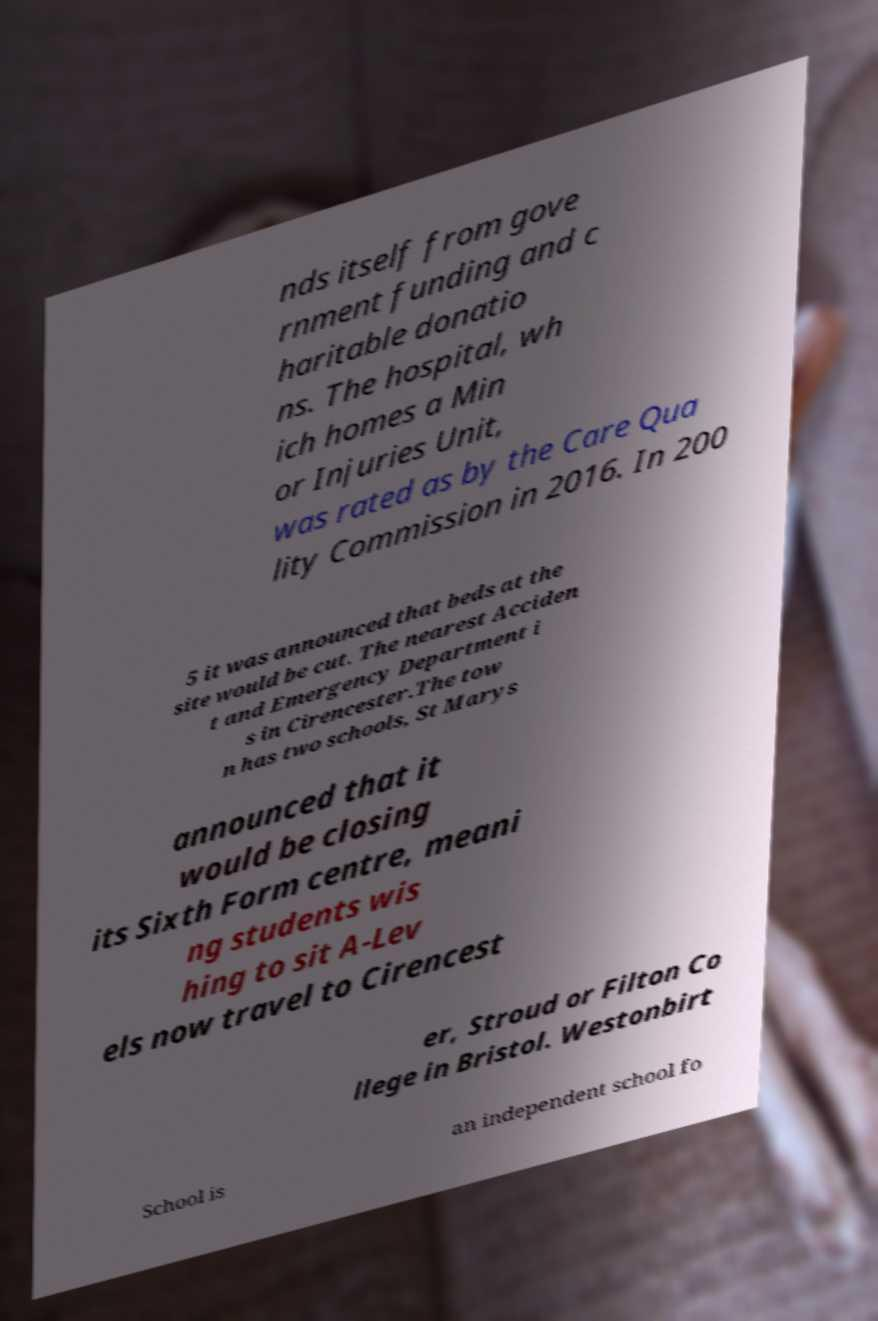I need the written content from this picture converted into text. Can you do that? nds itself from gove rnment funding and c haritable donatio ns. The hospital, wh ich homes a Min or Injuries Unit, was rated as by the Care Qua lity Commission in 2016. In 200 5 it was announced that beds at the site would be cut. The nearest Acciden t and Emergency Department i s in Cirencester.The tow n has two schools, St Marys announced that it would be closing its Sixth Form centre, meani ng students wis hing to sit A-Lev els now travel to Cirencest er, Stroud or Filton Co llege in Bristol. Westonbirt School is an independent school fo 